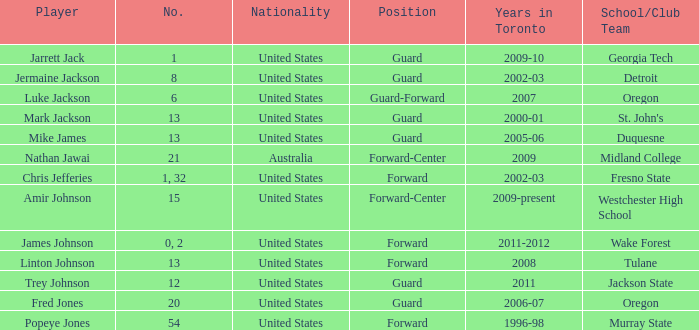Which school/association team is amir johnson a member of? Westchester High School. 